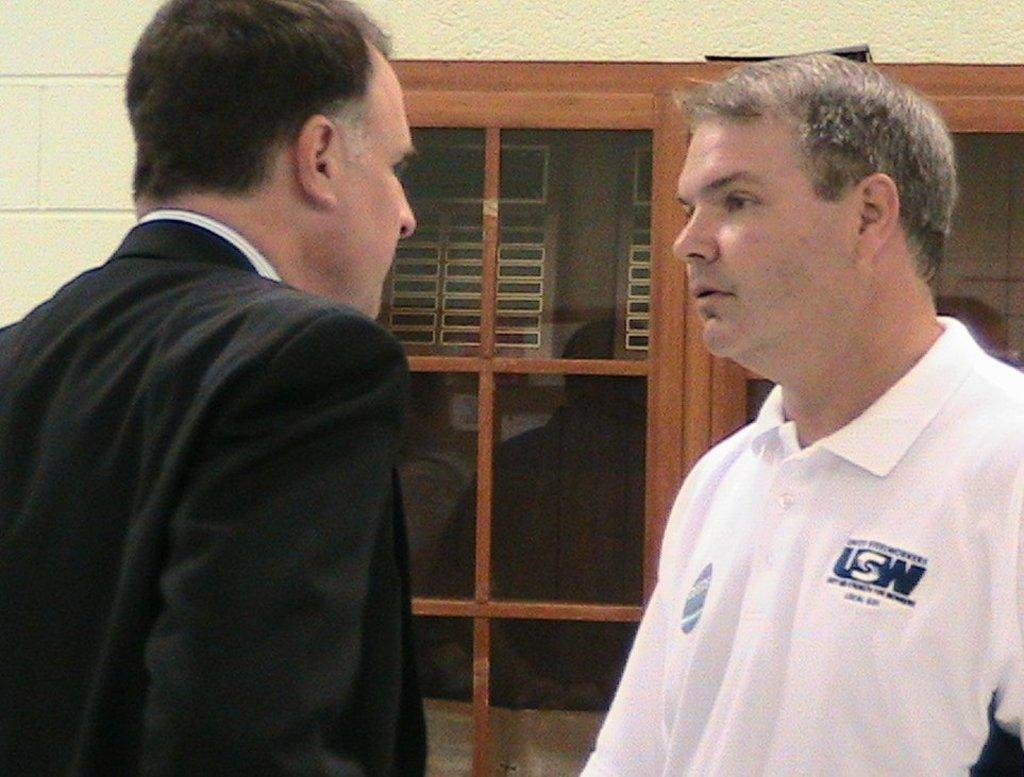How many men are in the image? There are two men in the image. What are the men wearing? The man on the left is wearing a black suit, and the man on the right is wearing a white t-shirt. What can be seen in the background of the image? There is a wall and a window in the background of the image. How many snails are crawling on the wall in the image? There are no snails visible in the image; only the two men and the wall are present. What type of rail is used to support the window in the image? There is no rail present in the image; only the wall and the window are visible. 